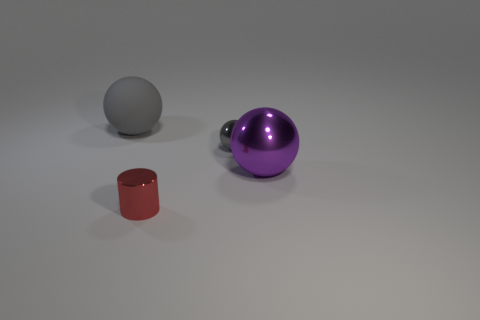Add 1 red cylinders. How many objects exist? 5 Subtract all purple balls. How many balls are left? 2 Subtract all metallic spheres. How many spheres are left? 1 Subtract all spheres. How many objects are left? 1 Subtract 1 cylinders. How many cylinders are left? 0 Add 1 large matte balls. How many large matte balls exist? 2 Subtract 0 brown blocks. How many objects are left? 4 Subtract all blue cylinders. Subtract all brown cubes. How many cylinders are left? 1 Subtract all blue cylinders. How many yellow spheres are left? 0 Subtract all metallic cylinders. Subtract all tiny red objects. How many objects are left? 2 